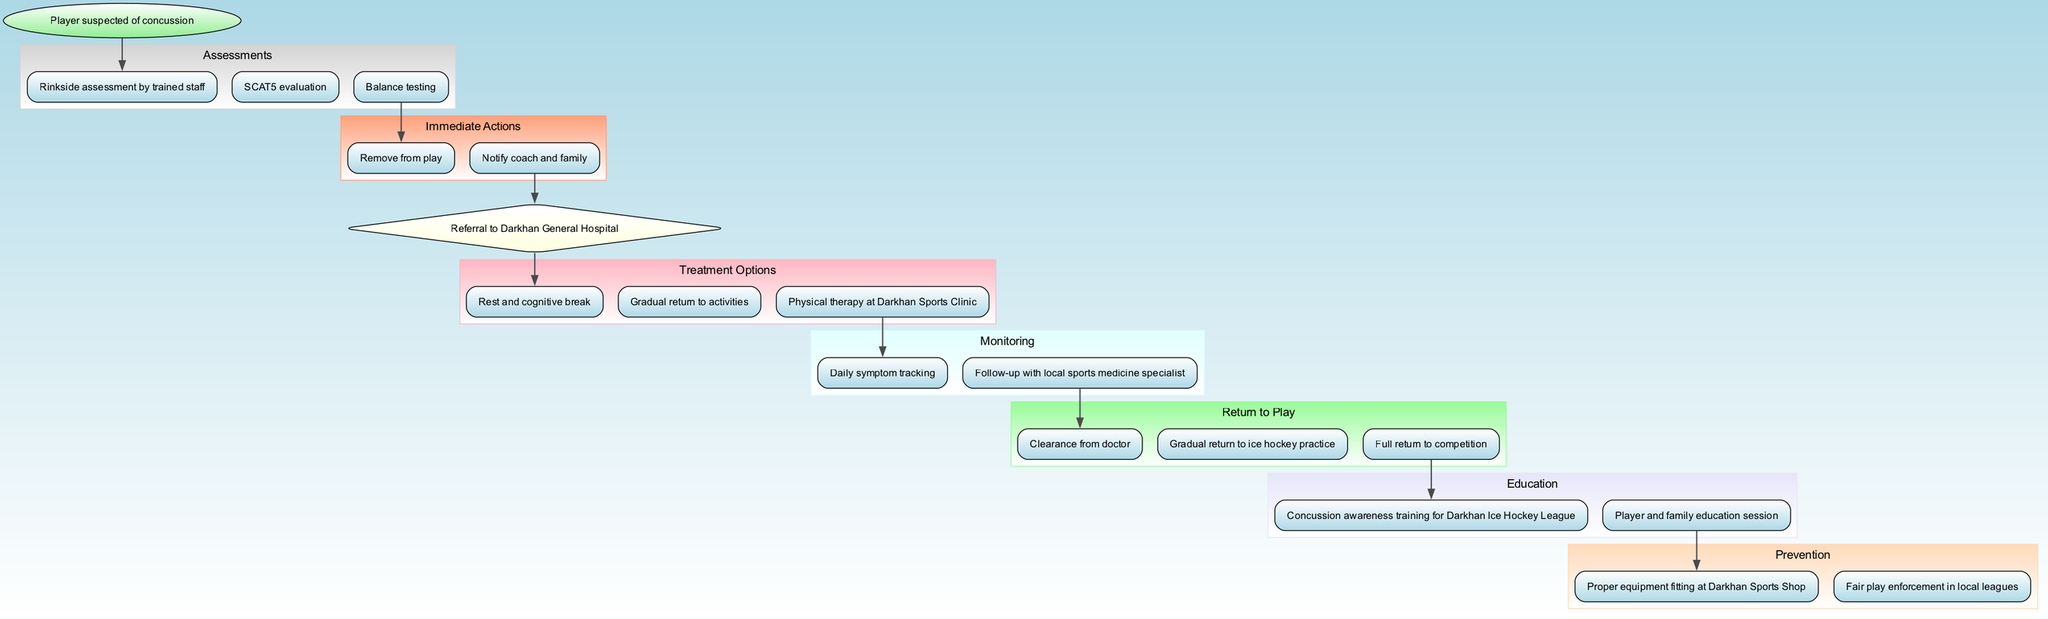What's the starting point of the clinical pathway? The pathway begins with the node labeled "Player suspected of concussion", which is the starting point highlighted in the diagram.
Answer: Player suspected of concussion How many immediate actions are listed? By counting the nodes in the "Immediate Actions" section, there are two actions specified: "Remove from play" and "Notify coach and family".
Answer: 2 What is the next step after the SCAT5 evaluation? The edge from "SCAT5 evaluation" leads to the "Remove from play" action, indicating that it is the next step following the evaluation.
Answer: Remove from play What medical evaluation is indicated in the pathway? The pathway specifies "Referral to Darkhan General Hospital" as the medical evaluation that follows from the immediate actions taken.
Answer: Referral to Darkhan General Hospital Which treatment option is focused on gradual activity resumption? The option "Gradual return to activities" directly addresses the resumption of activities in the treatment options section, specifically mentioned for recovery from a concussion.
Answer: Gradual return to activities After treatment, which step comes before returning to competition? The edge from "Gradual return to ice hockey practice" leads to "Full return to competition", indicating that practice is a prerequisite before full competition can occur.
Answer: Full return to competition What education is provided regarding concussion awareness? "Concussion awareness training for Darkhan Ice Hockey League" is stated in the education section, which focuses on raising awareness about concussions.
Answer: Concussion awareness training for Darkhan Ice Hockey League How many different sections are there in the pathway? By reviewing the clustered sections—Assessments, Immediate Actions, Medical Evaluation, Treatment Options, Monitoring, Return to Play, Education, and Prevention—there are a total of eight distinct sections in the pathway.
Answer: 8 What action must be taken before a player can return to ice hockey practice? The pathway emphasizes the need for "Clearance from doctor" as an essential action that must occur before a player can proceed to practice.
Answer: Clearance from doctor 